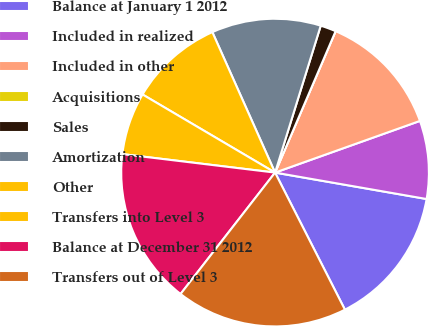Convert chart. <chart><loc_0><loc_0><loc_500><loc_500><pie_chart><fcel>Balance at January 1 2012<fcel>Included in realized<fcel>Included in other<fcel>Acquisitions<fcel>Sales<fcel>Amortization<fcel>Other<fcel>Transfers into Level 3<fcel>Balance at December 31 2012<fcel>Transfers out of Level 3<nl><fcel>14.75%<fcel>8.2%<fcel>13.11%<fcel>0.0%<fcel>1.64%<fcel>11.48%<fcel>9.84%<fcel>6.56%<fcel>16.39%<fcel>18.03%<nl></chart> 